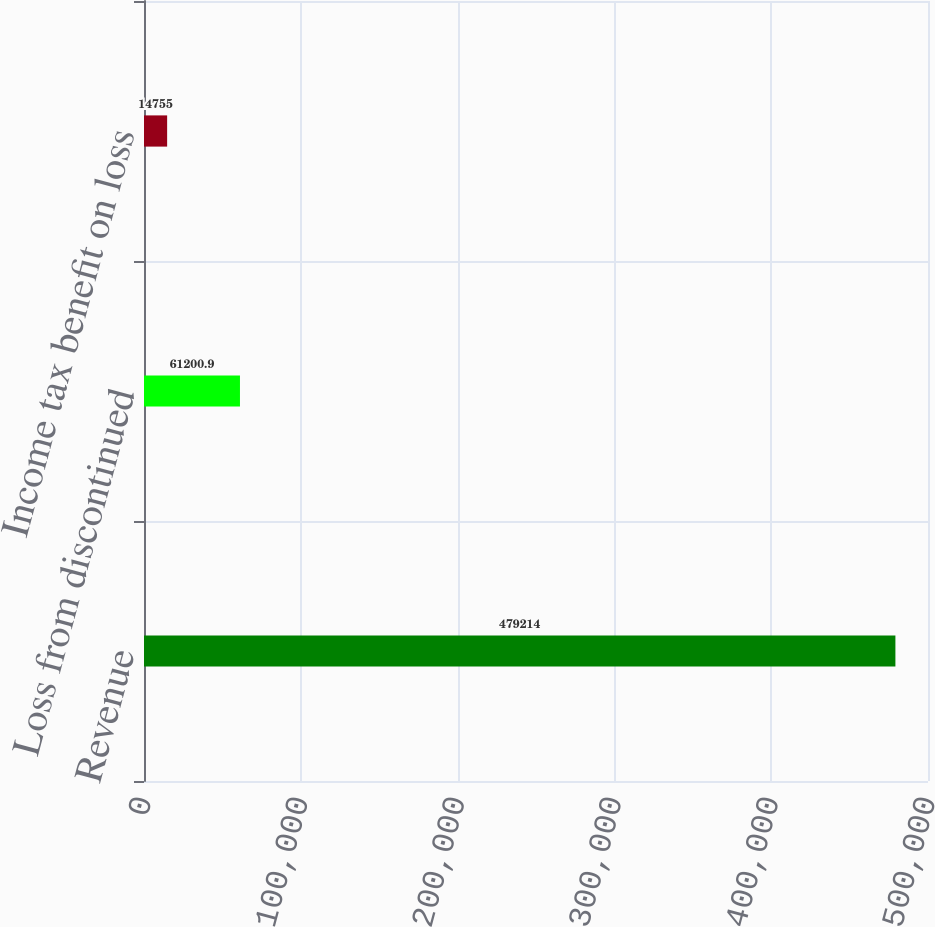Convert chart to OTSL. <chart><loc_0><loc_0><loc_500><loc_500><bar_chart><fcel>Revenue<fcel>Loss from discontinued<fcel>Income tax benefit on loss<nl><fcel>479214<fcel>61200.9<fcel>14755<nl></chart> 